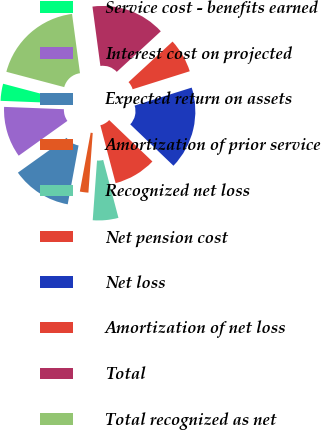Convert chart. <chart><loc_0><loc_0><loc_500><loc_500><pie_chart><fcel>Service cost - benefits earned<fcel>Interest cost on projected<fcel>Expected return on assets<fcel>Amortization of prior service<fcel>Recognized net loss<fcel>Net pension cost<fcel>Net loss<fcel>Amortization of net loss<fcel>Total<fcel>Total recognized as net<nl><fcel>3.5%<fcel>10.49%<fcel>12.23%<fcel>1.75%<fcel>5.25%<fcel>8.74%<fcel>17.02%<fcel>6.99%<fcel>15.27%<fcel>18.77%<nl></chart> 